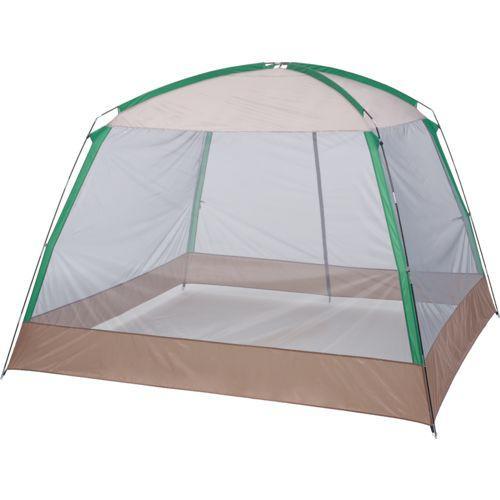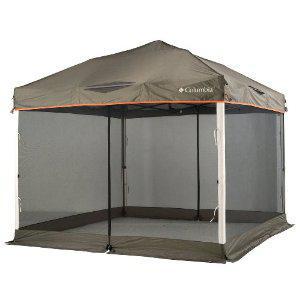The first image is the image on the left, the second image is the image on the right. For the images displayed, is the sentence "Both tents are shown without a background." factually correct? Answer yes or no. Yes. The first image is the image on the left, the second image is the image on the right. Examine the images to the left and right. Is the description "The structure in one of the images is standing upon a tiled floor." accurate? Answer yes or no. No. 